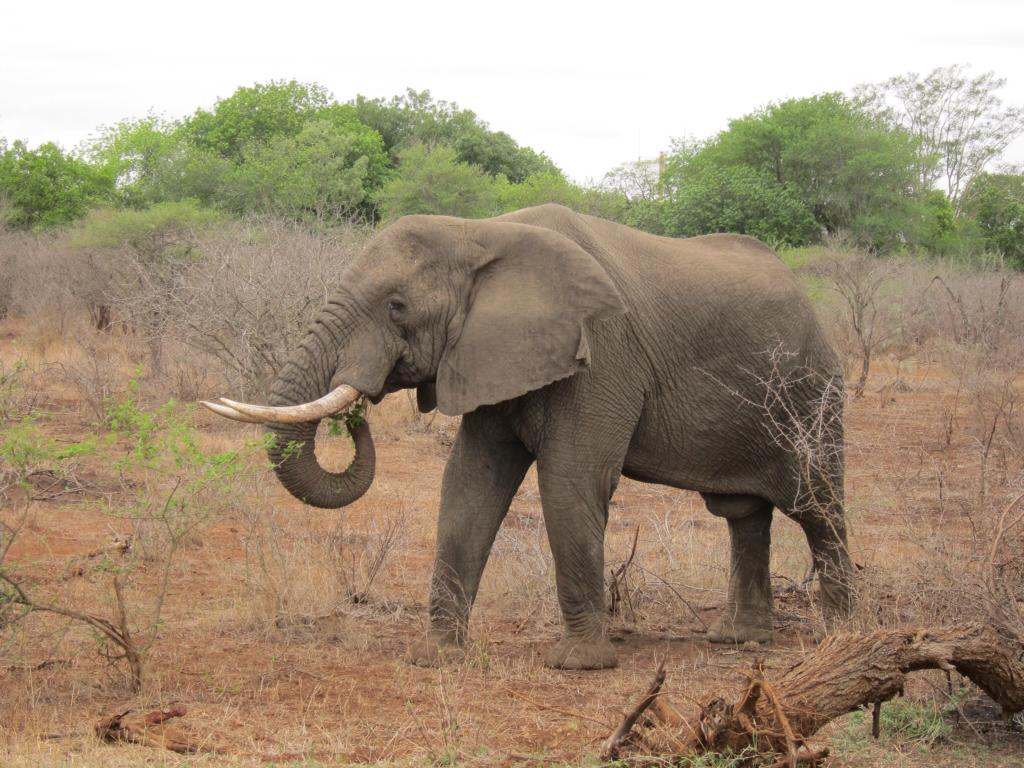What animal is the main subject of the picture? There is an elephant in the picture. What is the elephant's position in the image? The elephant is standing on the ground. What can be seen in the background of the picture? There are trees, plants, and the sky visible in the background of the picture. What type of force is being exerted by the goose in the image? There is no goose present in the image, so it is not possible to determine any force being exerted by a goose. What is the elephant using to cook in the image? There is no pot or cooking activity depicted in the image; the elephant is simply standing on the ground. 